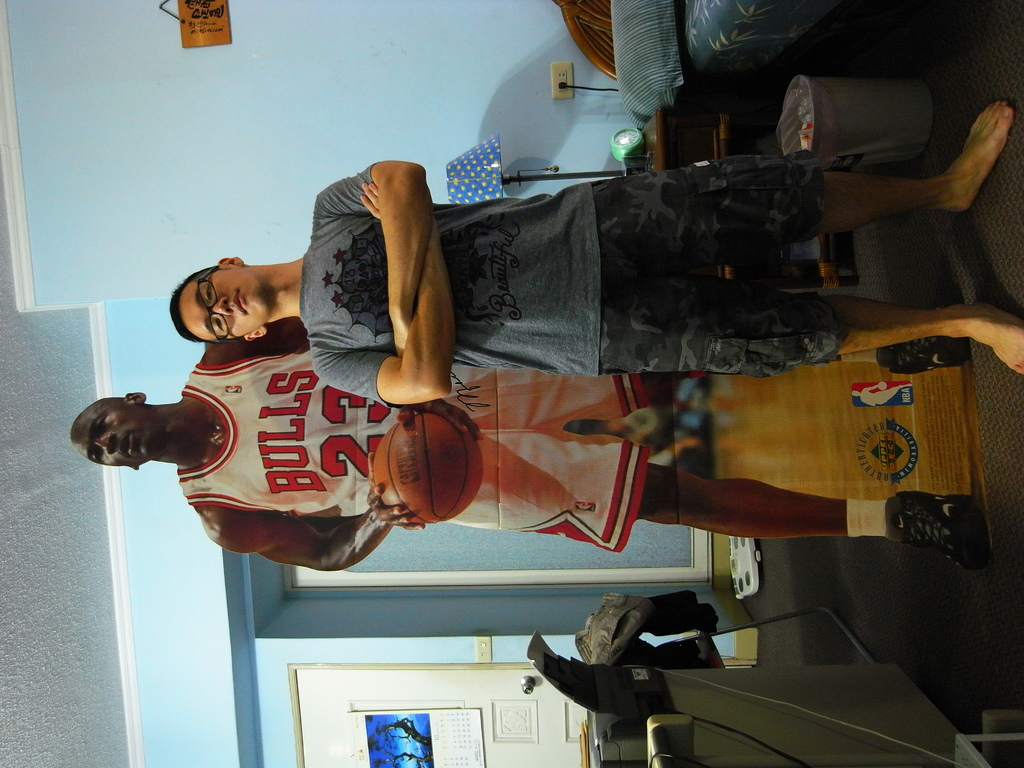Provide a one-sentence caption for the provided image. A man poses in his room with a life-size poster of Michael Jordan, emulating his idol by wearing a matching Bulls jersey and basketball shorts. 